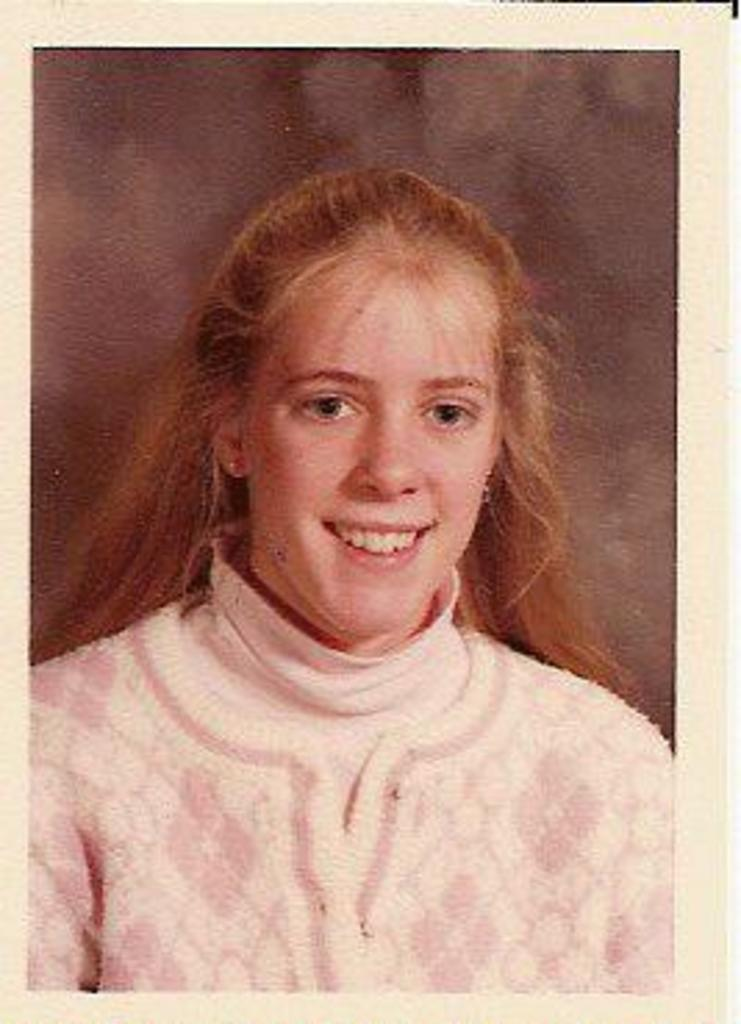What is the main subject of the image? There is a photograph of a woman in the image. What is the woman in the photograph doing? The woman in the photograph is smiling. How many people are jumping in the image? There are no people jumping in the image; it only features a photograph of a woman. What is the occupation of the woman in the image? The occupation of the woman in the image cannot be determined from the photograph. 